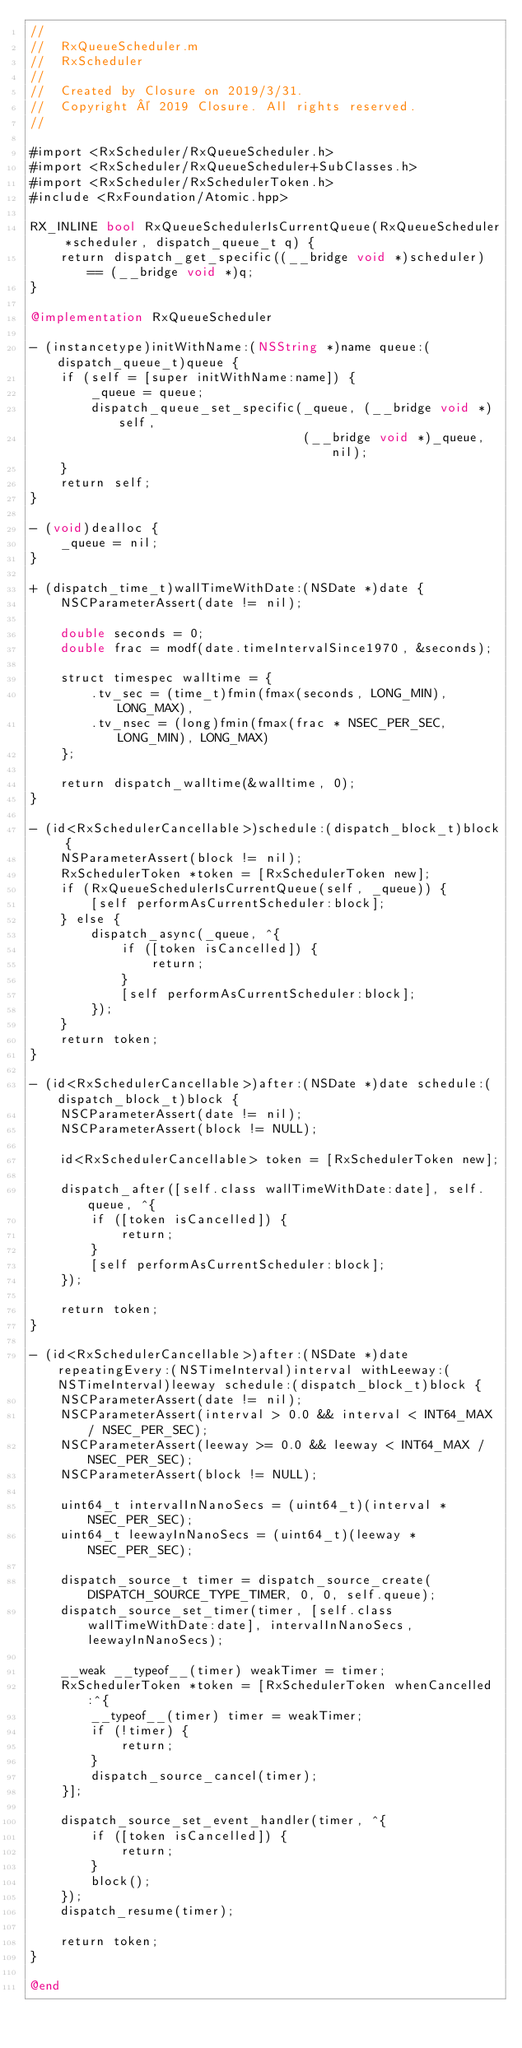Convert code to text. <code><loc_0><loc_0><loc_500><loc_500><_ObjectiveC_>//
//  RxQueueScheduler.m
//  RxScheduler
//
//  Created by Closure on 2019/3/31.
//  Copyright © 2019 Closure. All rights reserved.
//

#import <RxScheduler/RxQueueScheduler.h>
#import <RxScheduler/RxQueueScheduler+SubClasses.h>
#import <RxScheduler/RxSchedulerToken.h>
#include <RxFoundation/Atomic.hpp>

RX_INLINE bool RxQueueSchedulerIsCurrentQueue(RxQueueScheduler *scheduler, dispatch_queue_t q) {
    return dispatch_get_specific((__bridge void *)scheduler) == (__bridge void *)q;
}

@implementation RxQueueScheduler

- (instancetype)initWithName:(NSString *)name queue:(dispatch_queue_t)queue {
    if (self = [super initWithName:name]) {
        _queue = queue;
        dispatch_queue_set_specific(_queue, (__bridge void *)self,
                                    (__bridge void *)_queue, nil);
    }
    return self;
}

- (void)dealloc {
    _queue = nil;
}

+ (dispatch_time_t)wallTimeWithDate:(NSDate *)date {
    NSCParameterAssert(date != nil);
    
    double seconds = 0;
    double frac = modf(date.timeIntervalSince1970, &seconds);
    
    struct timespec walltime = {
        .tv_sec = (time_t)fmin(fmax(seconds, LONG_MIN), LONG_MAX),
        .tv_nsec = (long)fmin(fmax(frac * NSEC_PER_SEC, LONG_MIN), LONG_MAX)
    };
    
    return dispatch_walltime(&walltime, 0);
}

- (id<RxSchedulerCancellable>)schedule:(dispatch_block_t)block {
    NSParameterAssert(block != nil);
    RxSchedulerToken *token = [RxSchedulerToken new];
    if (RxQueueSchedulerIsCurrentQueue(self, _queue)) {
        [self performAsCurrentScheduler:block];
    } else {
        dispatch_async(_queue, ^{
            if ([token isCancelled]) {
                return;
            }
            [self performAsCurrentScheduler:block];
        });
    }
    return token;
}

- (id<RxSchedulerCancellable>)after:(NSDate *)date schedule:(dispatch_block_t)block {
    NSCParameterAssert(date != nil);
    NSCParameterAssert(block != NULL);
    
    id<RxSchedulerCancellable> token = [RxSchedulerToken new];
    
    dispatch_after([self.class wallTimeWithDate:date], self.queue, ^{
        if ([token isCancelled]) {
            return;
        }
        [self performAsCurrentScheduler:block];
    });
    
    return token;
}

- (id<RxSchedulerCancellable>)after:(NSDate *)date repeatingEvery:(NSTimeInterval)interval withLeeway:(NSTimeInterval)leeway schedule:(dispatch_block_t)block {
    NSCParameterAssert(date != nil);
    NSCParameterAssert(interval > 0.0 && interval < INT64_MAX / NSEC_PER_SEC);
    NSCParameterAssert(leeway >= 0.0 && leeway < INT64_MAX / NSEC_PER_SEC);
    NSCParameterAssert(block != NULL);
    
    uint64_t intervalInNanoSecs = (uint64_t)(interval * NSEC_PER_SEC);
    uint64_t leewayInNanoSecs = (uint64_t)(leeway * NSEC_PER_SEC);
    
    dispatch_source_t timer = dispatch_source_create(DISPATCH_SOURCE_TYPE_TIMER, 0, 0, self.queue);
    dispatch_source_set_timer(timer, [self.class wallTimeWithDate:date], intervalInNanoSecs, leewayInNanoSecs);
    
    __weak __typeof__(timer) weakTimer = timer;
    RxSchedulerToken *token = [RxSchedulerToken whenCancelled:^{
        __typeof__(timer) timer = weakTimer;
        if (!timer) {
            return;
        }
        dispatch_source_cancel(timer);
    }];
    
    dispatch_source_set_event_handler(timer, ^{
        if ([token isCancelled]) {
            return;
        }
        block();
    });
    dispatch_resume(timer);
    
    return token;
}

@end
</code> 